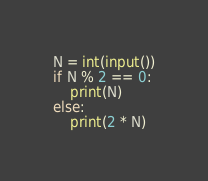<code> <loc_0><loc_0><loc_500><loc_500><_Python_>N = int(input())
if N % 2 == 0:
    print(N)
else:
    print(2 * N)
</code> 